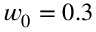Convert formula to latex. <formula><loc_0><loc_0><loc_500><loc_500>w _ { 0 } = 0 . 3</formula> 